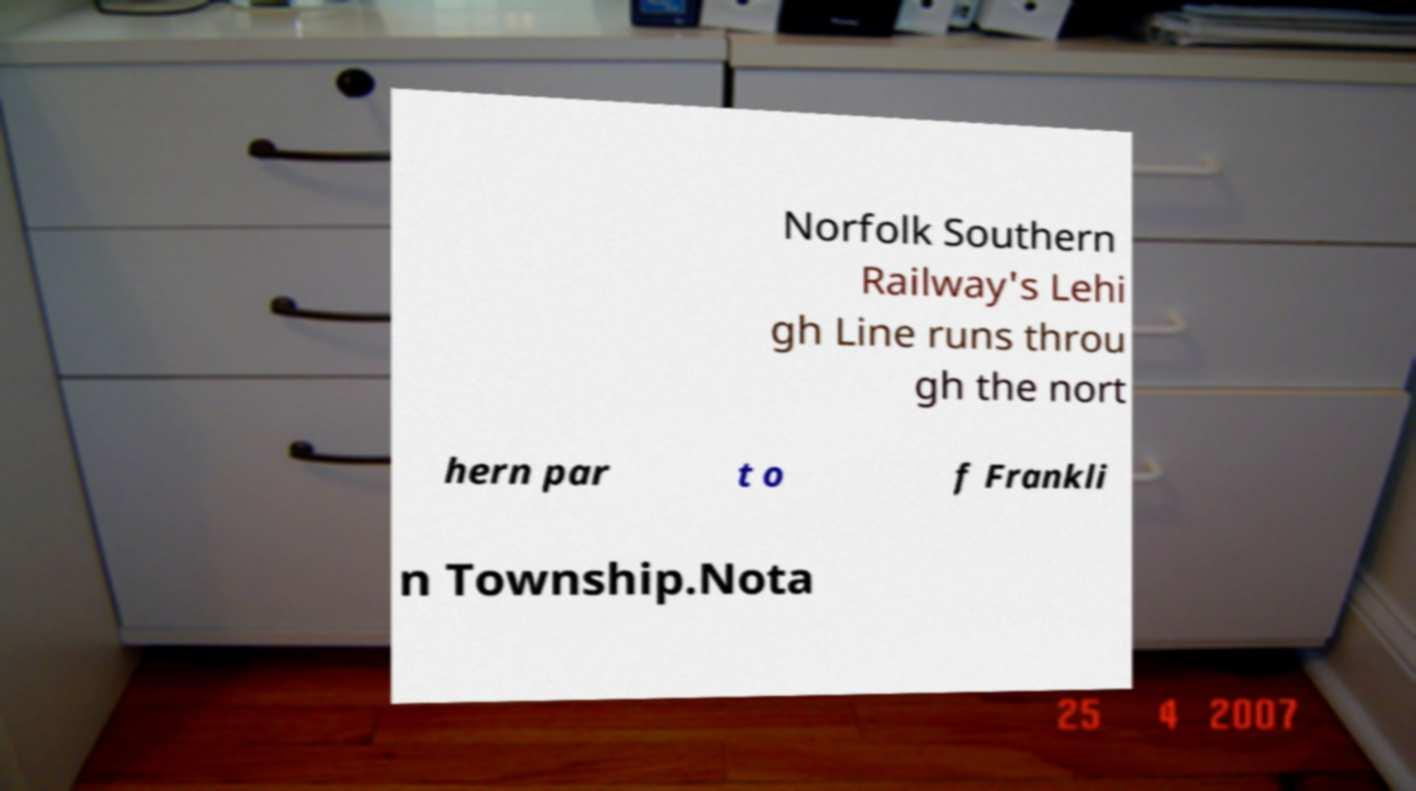I need the written content from this picture converted into text. Can you do that? Norfolk Southern Railway's Lehi gh Line runs throu gh the nort hern par t o f Frankli n Township.Nota 